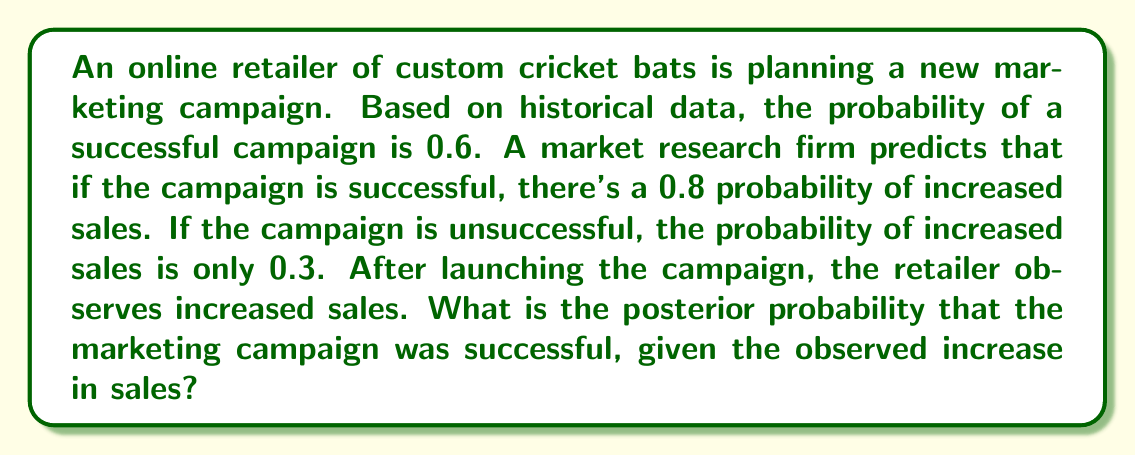Can you answer this question? Let's approach this problem using Bayesian inference:

1. Define our events:
   A: The marketing campaign is successful
   B: Increased sales are observed

2. Given probabilities:
   P(A) = 0.6 (prior probability of campaign success)
   P(B|A) = 0.8 (probability of increased sales given campaign success)
   P(B|not A) = 0.3 (probability of increased sales given campaign failure)

3. We want to find P(A|B) using Bayes' theorem:

   $$P(A|B) = \frac{P(B|A) \cdot P(A)}{P(B)}$$

4. Calculate P(B) using the law of total probability:
   
   $$P(B) = P(B|A) \cdot P(A) + P(B|not A) \cdot P(not A)$$
   $$P(B) = 0.8 \cdot 0.6 + 0.3 \cdot (1 - 0.6)$$
   $$P(B) = 0.48 + 0.12 = 0.6$$

5. Now we can apply Bayes' theorem:

   $$P(A|B) = \frac{0.8 \cdot 0.6}{0.6} = \frac{0.48}{0.6} = 0.8$$

Therefore, the posterior probability that the marketing campaign was successful, given the observed increase in sales, is 0.8 or 80%.
Answer: 0.8 